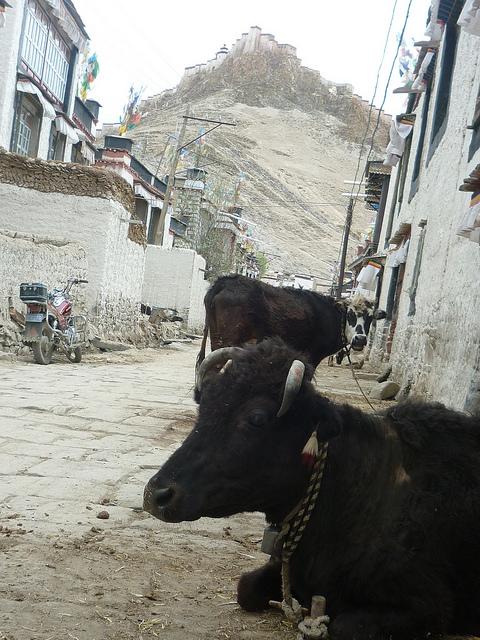How many animals are alive?
Quick response, please. 2. Are the animals fenced in?
Give a very brief answer. No. Is there a motorcycle in the picture?
Write a very short answer. Yes. Are there any people in the photo?
Be succinct. No. 